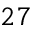<formula> <loc_0><loc_0><loc_500><loc_500>2 7</formula> 